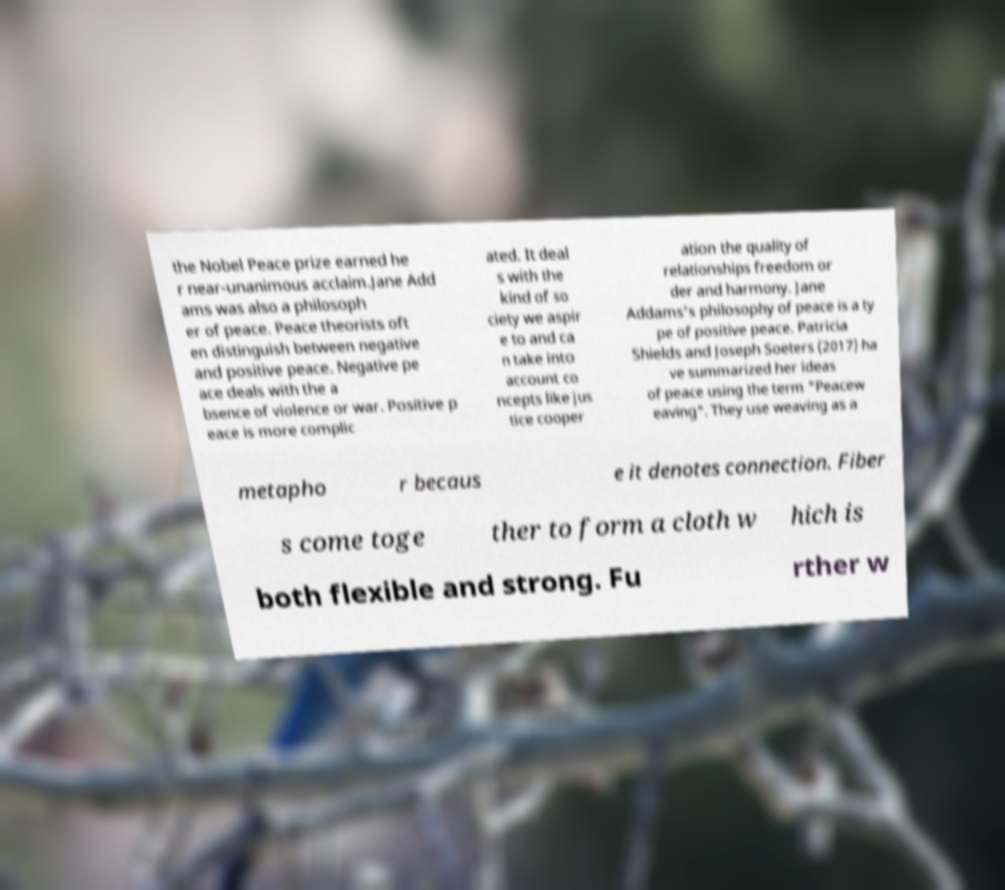What messages or text are displayed in this image? I need them in a readable, typed format. the Nobel Peace prize earned he r near-unanimous acclaim.Jane Add ams was also a philosoph er of peace. Peace theorists oft en distinguish between negative and positive peace. Negative pe ace deals with the a bsence of violence or war. Positive p eace is more complic ated. It deal s with the kind of so ciety we aspir e to and ca n take into account co ncepts like jus tice cooper ation the quality of relationships freedom or der and harmony. Jane Addams's philosophy of peace is a ty pe of positive peace. Patricia Shields and Joseph Soeters (2017) ha ve summarized her ideas of peace using the term "Peacew eaving". They use weaving as a metapho r becaus e it denotes connection. Fiber s come toge ther to form a cloth w hich is both flexible and strong. Fu rther w 